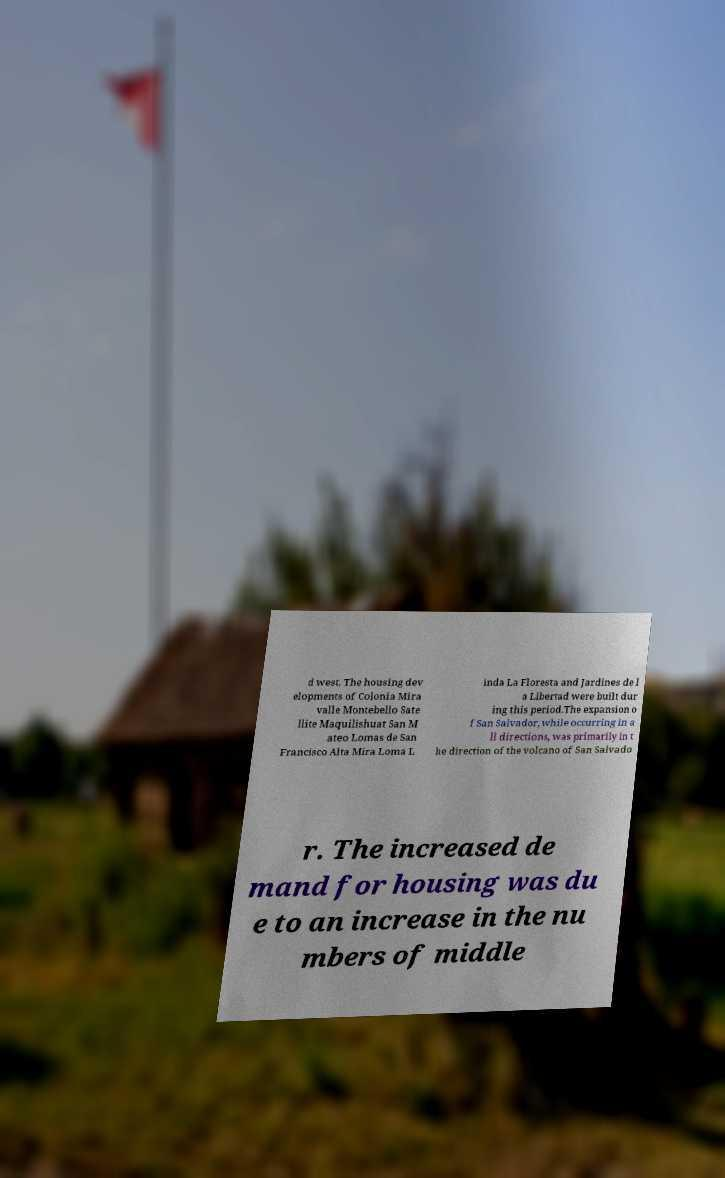Please identify and transcribe the text found in this image. d west. The housing dev elopments of Colonia Mira valle Montebello Sate llite Maquilishuat San M ateo Lomas de San Francisco Alta Mira Loma L inda La Floresta and Jardines de l a Libertad were built dur ing this period.The expansion o f San Salvador, while occurring in a ll directions, was primarily in t he direction of the volcano of San Salvado r. The increased de mand for housing was du e to an increase in the nu mbers of middle 